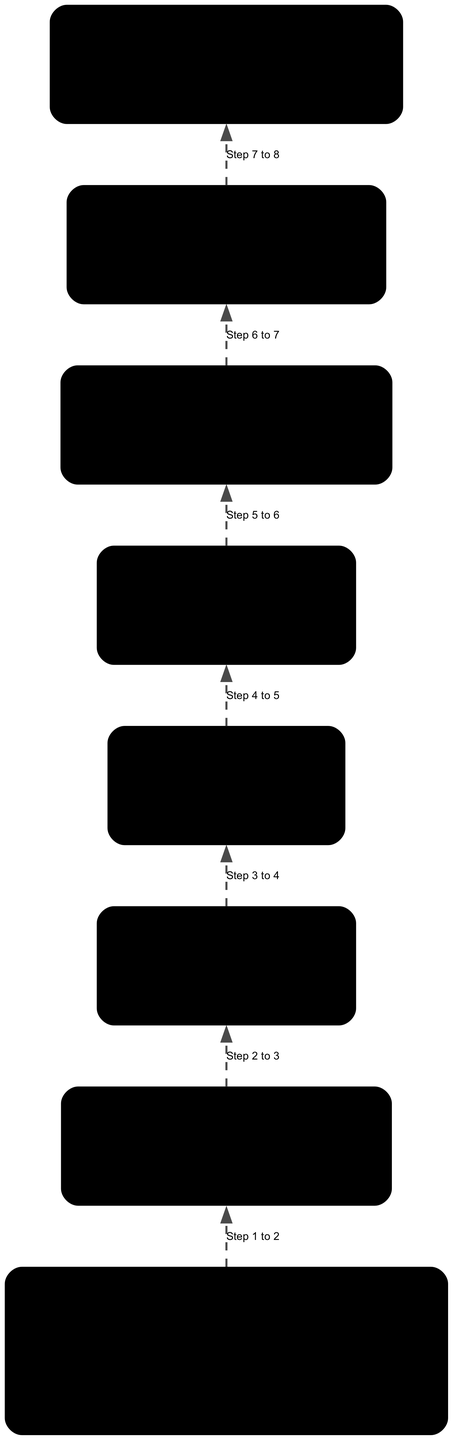What is the name of the centralized coordination hub? The diagram indicates that the centralized coordination hub is named "Hawthorne Transportation Incident Command Center." This information can be found directly under the "Coordination Center" node.
Answer: Hawthorne Transportation Incident Command Center How many steps are included in the Initial Incident Assessment? To find the answer, one must look at the "InitialAssessment" node, which lists four specific steps: report receipt, first responder deployment, site assessment, and preliminary resource requirements identification. Thus, the total count is four.
Answer: 4 What is the first step in the Emergency Response Plan? The diagram flows upward starting from "After-Action Review and Improvement," leading to the "Recovery and Debris Clearance," followed by "Traffic Management," "Evacuation and Shelter Management," "Public Communication and Alerts," "Resource Allocation and Mobilization," and finally "Initial Incident Assessment." Therefore, the first step is "Initial Incident Assessment."
Answer: Initial Incident Assessment What is the last activity suggested in the Recovery Operations? The last activity under the "RecoveryOperations" node is "Assessment of long-term infrastructure needs." This can be identified by reviewing the listed activities, where this is the fourth item.
Answer: Assessment of long-term infrastructure needs Which method is NOT used for Public Communication and Alerts? The "PublicCommunication" node lists several methods, including social media updates, local news broadcasts, emergency alert systems, and public information officers. Since there is no mention of 'text alerts' in the list, we can conclude that it is not among the methods used.
Answer: Text alerts Which team is allocated in Resource Allocation and Mobilization? The diagram specifies several resources in the "ResourceAllocation" node, including EMS Units, Fire and Rescue Services, Police Department, and Public Works. Therefore, we can say that the Police Department is one of the teams allocated during this phase.
Answer: Police Department What is a component of Traffic Management? As detailed in the "TrafficManagement" node, components include traffic signal adjustments, route diversions and detours, signage and information dissemination, and coordination with regional traffic control centers. Thus, just one example component would be 'traffic signal adjustments.'
Answer: Traffic signal adjustments What is the purpose of the After-Action Review? The diagram outlines tasks under the "AfterActionReview" node, which include incident debriefing, performance evaluation, identification of lessons learned, and updating and improving emergency response plans. Therefore, the purpose of the After-Action Review is primarily to improve future incident responses based on evaluations and learnings.
Answer: Improve future incident responses 